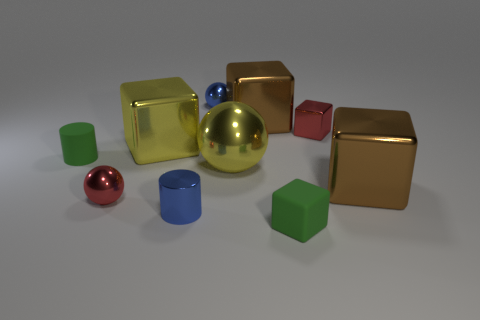Do the tiny rubber cylinder and the tiny rubber cube have the same color?
Give a very brief answer. Yes. Is there any other thing that has the same color as the large metallic sphere?
Your answer should be compact. Yes. What is the size of the red metallic ball in front of the blue metal object behind the blue metal thing that is in front of the red metallic sphere?
Make the answer very short. Small. There is a red metal thing that is on the right side of the tiny blue object on the left side of the small blue metallic ball; what is its shape?
Provide a short and direct response. Cube. There is a rubber object behind the big ball; is its color the same as the rubber block?
Provide a short and direct response. Yes. There is a large block that is right of the large yellow metallic sphere and behind the yellow metallic ball; what color is it?
Offer a terse response. Brown. Is there a small brown sphere that has the same material as the tiny blue ball?
Ensure brevity in your answer.  No. The green rubber block has what size?
Make the answer very short. Small. What size is the green object that is behind the brown shiny cube that is in front of the small metallic block?
Make the answer very short. Small. How many blue rubber cylinders are there?
Offer a very short reply. 0. 